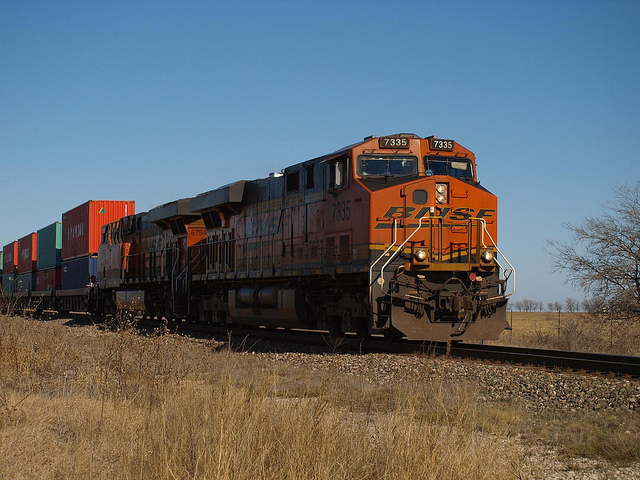<image>What are the letters on the train engine? I am not sure about the exact letters on the train engine. It can be 'bnse' or 'boise'. What are the letters on the train engine? I am not sure what the letters on the train engine are. It can be seen 'bnse', 'boise', or 'boys'. 